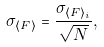Convert formula to latex. <formula><loc_0><loc_0><loc_500><loc_500>\sigma _ { \langle F \rangle } = \frac { \sigma _ { \langle F \rangle _ { i } } } { \sqrt { N } } ,</formula> 